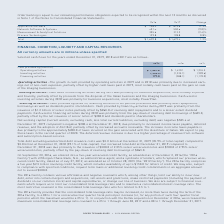According to Roper Technologies's financial document, What was the cause of growth in cash provided by operating activities in 2018 and 2019? Based on the financial document, the answer is increased earnings net of non-cash expenses, partially offset by higher cash taxes paid in 2019, most notably cash taxes paid on the gain on sale of the Imaging businesses. Also, How was the cash used in investing activities during 2018? primarily for business acquisitions, most notably PowerPlan. The document states: "Cash used in investing activities during 2018 was primarily for business acquisitions, most notably PowerPlan...." Also, How much was the cash provided by financing activities in 2019? According to the financial document, 177.0 (in millions). The relevant text states: "Financing activities 177.0 (388.1) (1,170.0)..." Additionally, Which year did operating activities provide the most cash? According to the financial document, 2019. The relevant text states: "2019 2018 2017..." Also, can you calculate: What is the change in cash provided by operating activities between 2018 and 2019? Based on the calculation: 1,461.8-1,430.1, the result is 31.7 (in millions). This is based on the information: "Operating activities $ 1,461.8 $ 1,430.1 $ 1,234.5 Operating activities $ 1,461.8 $ 1,430.1 $ 1,234.5..." The key data points involved are: 1,430.1, 1,461.8. Also, can you calculate: What is the total amount of cash in 2019? Based on the calculation: 1,461.8+(-1,296.0)+177.0 , the result is 342.8 (in millions). This is based on the information: "Investing activities (1,296.0) (1,335.1) (209.6) Operating activities $ 1,461.8 $ 1,430.1 $ 1,234.5 Financing activities 177.0 (388.1) (1,170.0)..." The key data points involved are: 1,296.0, 1,461.8, 177.0. 